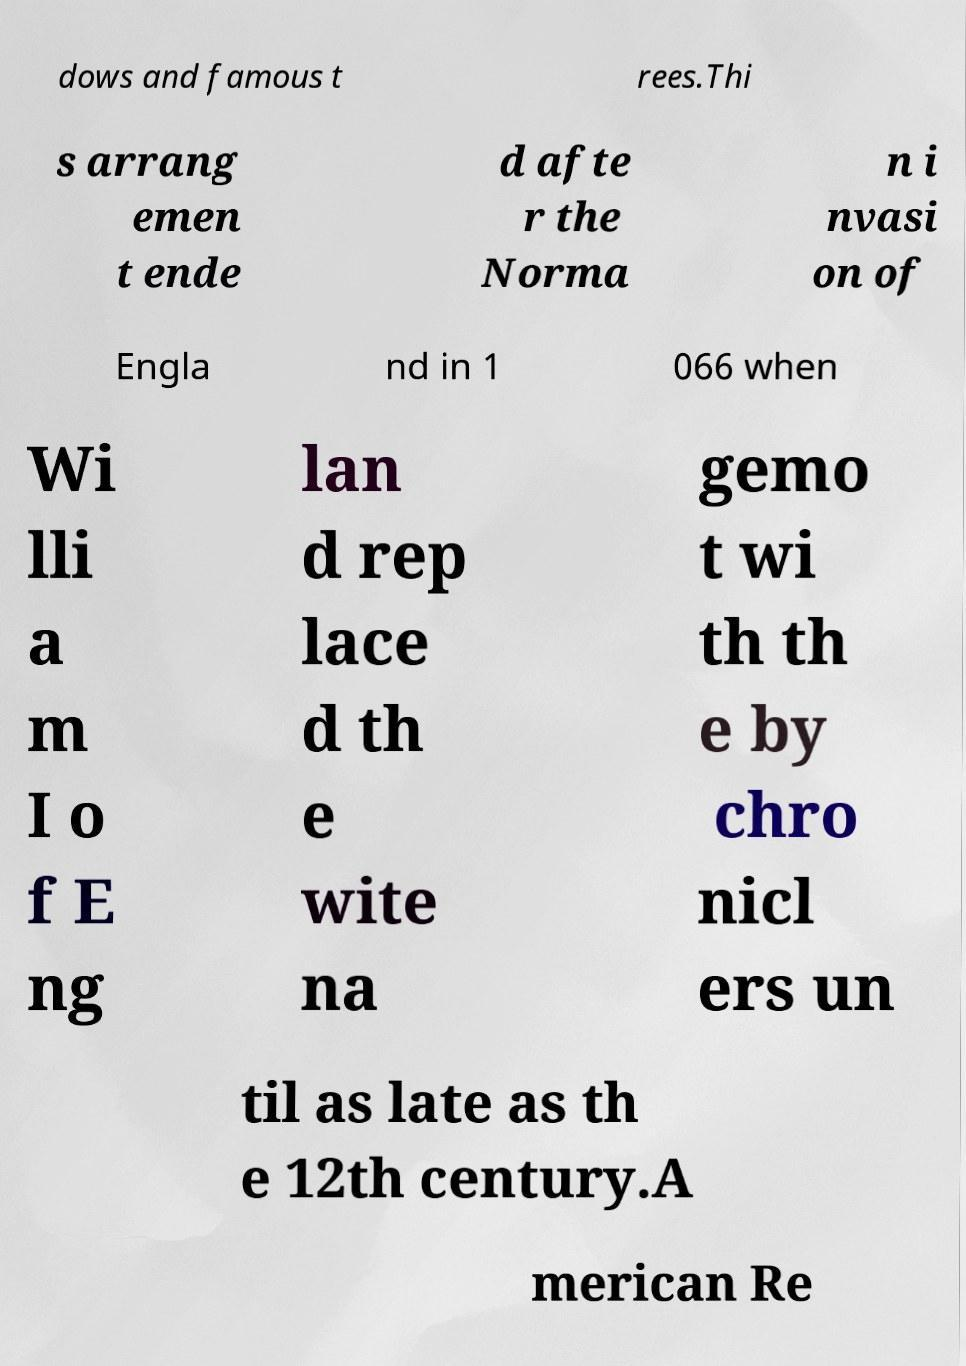What messages or text are displayed in this image? I need them in a readable, typed format. dows and famous t rees.Thi s arrang emen t ende d afte r the Norma n i nvasi on of Engla nd in 1 066 when Wi lli a m I o f E ng lan d rep lace d th e wite na gemo t wi th th e by chro nicl ers un til as late as th e 12th century.A merican Re 